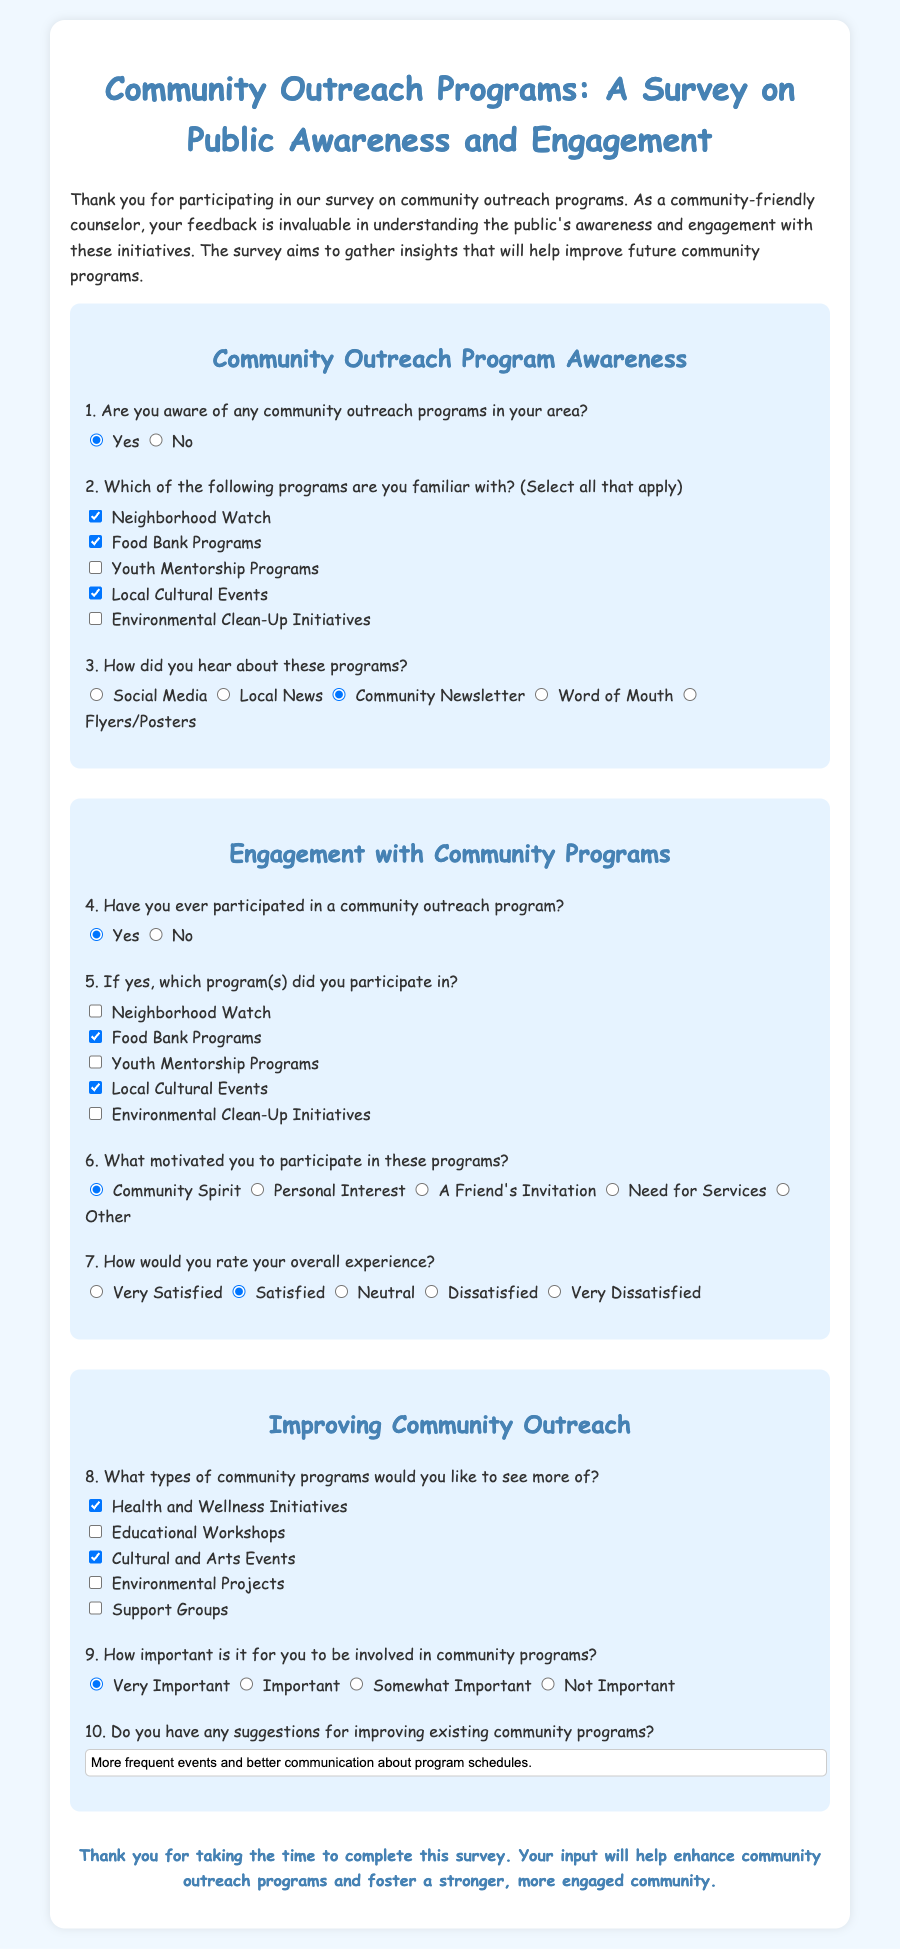What is the title of the survey? The title of the survey is clearly stated at the top of the document.
Answer: Community Outreach Programs: A Survey on Public Awareness and Engagement How many sections are there in the survey? The survey consists of three main sections that cover different themes related to community outreach.
Answer: Three What program is mentioned as a popular choice among respondents? The document lists specific community outreach programs, and some are selected by respondents.
Answer: Food Bank Programs What motivation option is provided related to joining community programs? There are several motivations listed for participating in community programs.
Answer: Community Spirit Which community program type is indicated as preferred by participants for future events? The document includes a question about preferred future programs which dominated choices.
Answer: Health and Wellness Initiatives What is the response option for public involvement in community programs deemed crucial? The survey asks respondents to rate the importance of being involved in community programs.
Answer: Very Important How did most respondents report hearing about the community outreach programs? The survey includes options about how respondents became aware of these programs.
Answer: Community Newsletter What is a suggested improvement mentioned in the survey? The document provides a space for suggestions to enhance community programs.
Answer: More frequent events and better communication about program schedules 